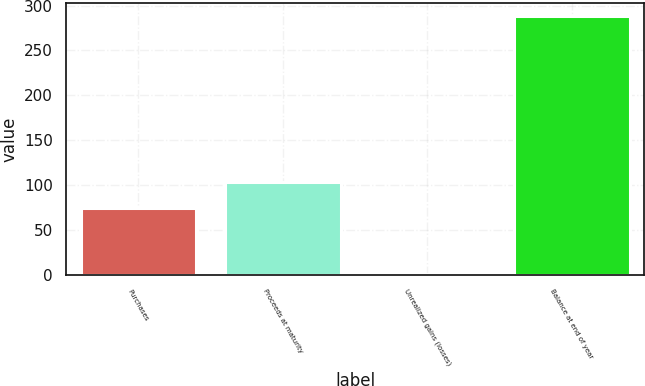Convert chart to OTSL. <chart><loc_0><loc_0><loc_500><loc_500><bar_chart><fcel>Purchases<fcel>Proceeds at maturity<fcel>Unrealized gains (losses)<fcel>Balance at end of year<nl><fcel>75<fcel>103.7<fcel>1<fcel>288<nl></chart> 